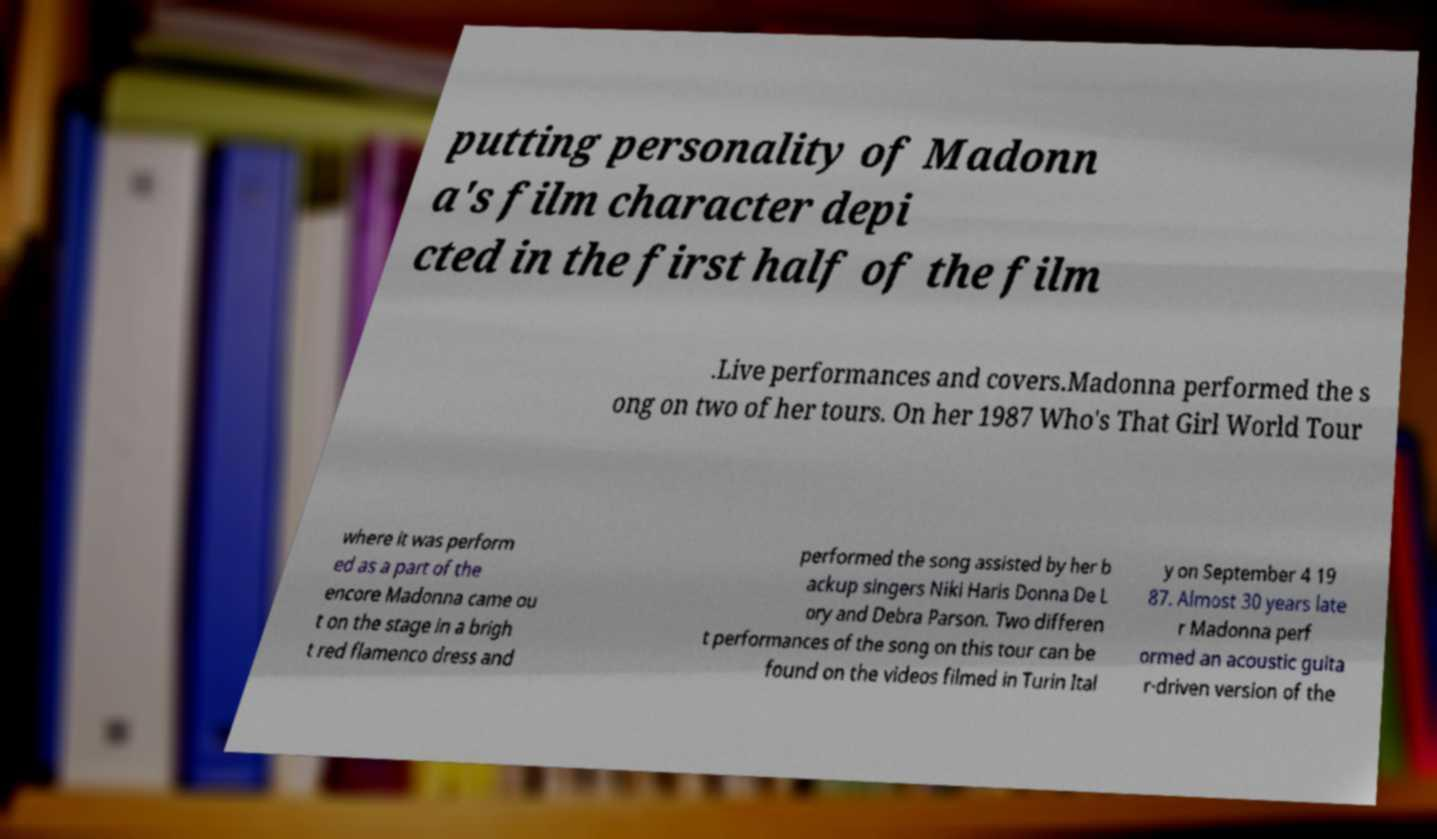Could you assist in decoding the text presented in this image and type it out clearly? putting personality of Madonn a's film character depi cted in the first half of the film .Live performances and covers.Madonna performed the s ong on two of her tours. On her 1987 Who's That Girl World Tour where it was perform ed as a part of the encore Madonna came ou t on the stage in a brigh t red flamenco dress and performed the song assisted by her b ackup singers Niki Haris Donna De L ory and Debra Parson. Two differen t performances of the song on this tour can be found on the videos filmed in Turin Ital y on September 4 19 87. Almost 30 years late r Madonna perf ormed an acoustic guita r-driven version of the 